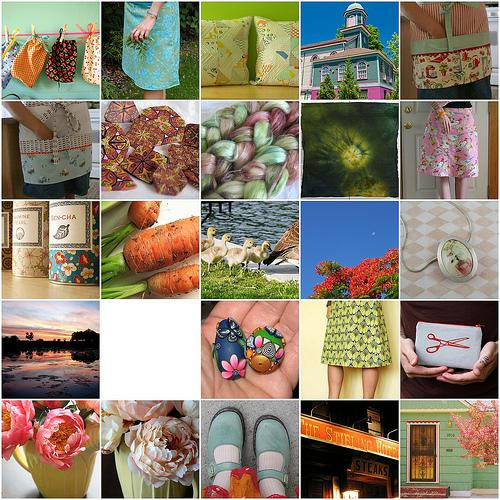Question: how many pillows are on the top line?
Choices:
A. Two.
B. One.
C. Three.
D. Four.
Answer with the letter. Answer: A Question: what color shoes are shown?
Choices:
A. Black.
B. White.
C. Grey.
D. Blue.
Answer with the letter. Answer: D Question: where are the pink flowers in the bottom line?
Choices:
A. First, second, and third square.
B. First, second, and fifth square.
C. Second, third, and fourth lines.
D. Fourth, fifth, and six circle.
Answer with the letter. Answer: B Question: what color skirt is shown on the top line?
Choices:
A. Blue.
B. White.
C. Black.
D. Red.
Answer with the letter. Answer: A Question: what color are the carrots?
Choices:
A. Purple.
B. White.
C. Green.
D. Orange.
Answer with the letter. Answer: D Question: what color flowers are in the third line?
Choices:
A. White.
B. Yellow.
C. Red.
D. Purple.
Answer with the letter. Answer: C 